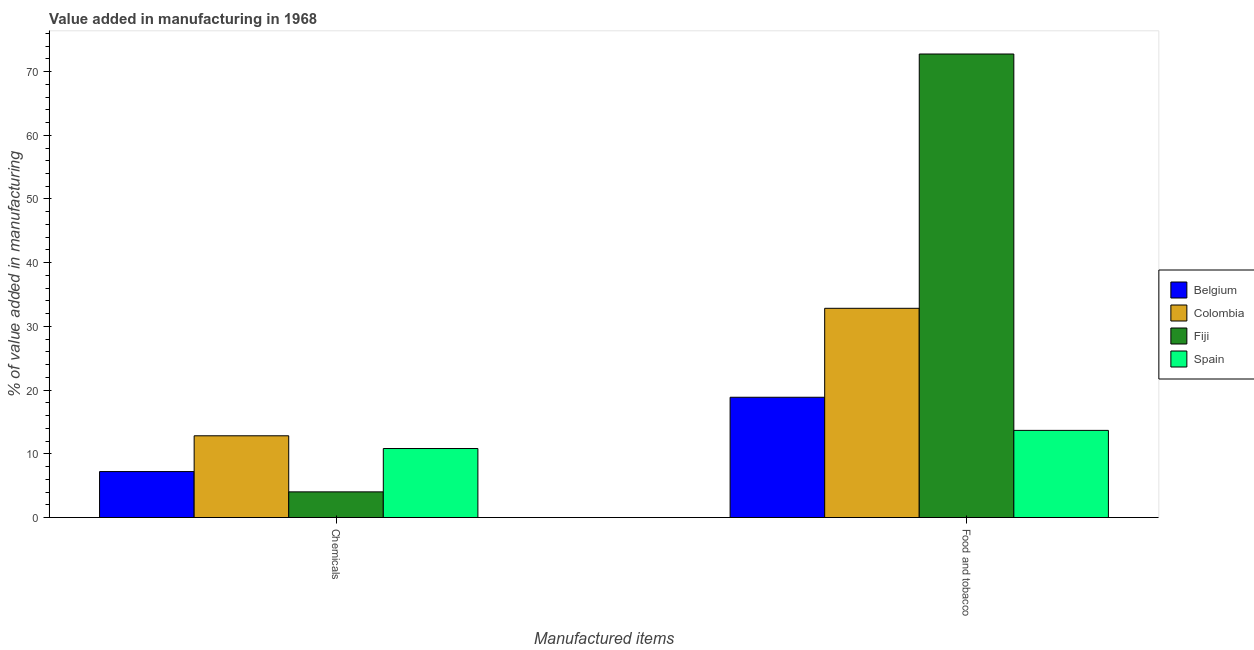How many different coloured bars are there?
Your answer should be compact. 4. How many groups of bars are there?
Offer a terse response. 2. What is the label of the 2nd group of bars from the left?
Make the answer very short. Food and tobacco. What is the value added by manufacturing food and tobacco in Spain?
Provide a succinct answer. 13.68. Across all countries, what is the maximum value added by  manufacturing chemicals?
Your answer should be very brief. 12.84. Across all countries, what is the minimum value added by manufacturing food and tobacco?
Your response must be concise. 13.68. What is the total value added by manufacturing food and tobacco in the graph?
Keep it short and to the point. 138.16. What is the difference between the value added by  manufacturing chemicals in Colombia and that in Belgium?
Your answer should be compact. 5.62. What is the difference between the value added by  manufacturing chemicals in Fiji and the value added by manufacturing food and tobacco in Colombia?
Make the answer very short. -28.81. What is the average value added by  manufacturing chemicals per country?
Offer a terse response. 8.73. What is the difference between the value added by manufacturing food and tobacco and value added by  manufacturing chemicals in Belgium?
Give a very brief answer. 11.66. What is the ratio of the value added by  manufacturing chemicals in Spain to that in Fiji?
Your answer should be very brief. 2.69. In how many countries, is the value added by manufacturing food and tobacco greater than the average value added by manufacturing food and tobacco taken over all countries?
Give a very brief answer. 1. What does the 4th bar from the right in Chemicals represents?
Provide a succinct answer. Belgium. Are the values on the major ticks of Y-axis written in scientific E-notation?
Offer a very short reply. No. Does the graph contain any zero values?
Your answer should be compact. No. How many legend labels are there?
Offer a terse response. 4. How are the legend labels stacked?
Keep it short and to the point. Vertical. What is the title of the graph?
Provide a succinct answer. Value added in manufacturing in 1968. Does "West Bank and Gaza" appear as one of the legend labels in the graph?
Offer a very short reply. No. What is the label or title of the X-axis?
Your answer should be compact. Manufactured items. What is the label or title of the Y-axis?
Keep it short and to the point. % of value added in manufacturing. What is the % of value added in manufacturing in Belgium in Chemicals?
Ensure brevity in your answer.  7.22. What is the % of value added in manufacturing of Colombia in Chemicals?
Your answer should be very brief. 12.84. What is the % of value added in manufacturing in Fiji in Chemicals?
Your response must be concise. 4.03. What is the % of value added in manufacturing of Spain in Chemicals?
Make the answer very short. 10.84. What is the % of value added in manufacturing in Belgium in Food and tobacco?
Your answer should be very brief. 18.88. What is the % of value added in manufacturing in Colombia in Food and tobacco?
Offer a very short reply. 32.84. What is the % of value added in manufacturing of Fiji in Food and tobacco?
Your response must be concise. 72.76. What is the % of value added in manufacturing in Spain in Food and tobacco?
Offer a very short reply. 13.68. Across all Manufactured items, what is the maximum % of value added in manufacturing of Belgium?
Your answer should be very brief. 18.88. Across all Manufactured items, what is the maximum % of value added in manufacturing of Colombia?
Provide a succinct answer. 32.84. Across all Manufactured items, what is the maximum % of value added in manufacturing in Fiji?
Give a very brief answer. 72.76. Across all Manufactured items, what is the maximum % of value added in manufacturing in Spain?
Your response must be concise. 13.68. Across all Manufactured items, what is the minimum % of value added in manufacturing of Belgium?
Give a very brief answer. 7.22. Across all Manufactured items, what is the minimum % of value added in manufacturing in Colombia?
Your answer should be very brief. 12.84. Across all Manufactured items, what is the minimum % of value added in manufacturing of Fiji?
Your response must be concise. 4.03. Across all Manufactured items, what is the minimum % of value added in manufacturing of Spain?
Ensure brevity in your answer.  10.84. What is the total % of value added in manufacturing of Belgium in the graph?
Your answer should be compact. 26.1. What is the total % of value added in manufacturing of Colombia in the graph?
Provide a succinct answer. 45.68. What is the total % of value added in manufacturing of Fiji in the graph?
Ensure brevity in your answer.  76.79. What is the total % of value added in manufacturing of Spain in the graph?
Ensure brevity in your answer.  24.52. What is the difference between the % of value added in manufacturing of Belgium in Chemicals and that in Food and tobacco?
Offer a very short reply. -11.66. What is the difference between the % of value added in manufacturing of Colombia in Chemicals and that in Food and tobacco?
Your answer should be compact. -20.01. What is the difference between the % of value added in manufacturing of Fiji in Chemicals and that in Food and tobacco?
Offer a terse response. -68.73. What is the difference between the % of value added in manufacturing of Spain in Chemicals and that in Food and tobacco?
Ensure brevity in your answer.  -2.85. What is the difference between the % of value added in manufacturing of Belgium in Chemicals and the % of value added in manufacturing of Colombia in Food and tobacco?
Keep it short and to the point. -25.63. What is the difference between the % of value added in manufacturing of Belgium in Chemicals and the % of value added in manufacturing of Fiji in Food and tobacco?
Offer a terse response. -65.54. What is the difference between the % of value added in manufacturing in Belgium in Chemicals and the % of value added in manufacturing in Spain in Food and tobacco?
Keep it short and to the point. -6.47. What is the difference between the % of value added in manufacturing in Colombia in Chemicals and the % of value added in manufacturing in Fiji in Food and tobacco?
Provide a succinct answer. -59.92. What is the difference between the % of value added in manufacturing in Colombia in Chemicals and the % of value added in manufacturing in Spain in Food and tobacco?
Give a very brief answer. -0.85. What is the difference between the % of value added in manufacturing of Fiji in Chemicals and the % of value added in manufacturing of Spain in Food and tobacco?
Your response must be concise. -9.65. What is the average % of value added in manufacturing in Belgium per Manufactured items?
Your answer should be compact. 13.05. What is the average % of value added in manufacturing of Colombia per Manufactured items?
Offer a terse response. 22.84. What is the average % of value added in manufacturing of Fiji per Manufactured items?
Ensure brevity in your answer.  38.39. What is the average % of value added in manufacturing in Spain per Manufactured items?
Your answer should be compact. 12.26. What is the difference between the % of value added in manufacturing in Belgium and % of value added in manufacturing in Colombia in Chemicals?
Give a very brief answer. -5.62. What is the difference between the % of value added in manufacturing in Belgium and % of value added in manufacturing in Fiji in Chemicals?
Ensure brevity in your answer.  3.19. What is the difference between the % of value added in manufacturing in Belgium and % of value added in manufacturing in Spain in Chemicals?
Ensure brevity in your answer.  -3.62. What is the difference between the % of value added in manufacturing in Colombia and % of value added in manufacturing in Fiji in Chemicals?
Provide a short and direct response. 8.8. What is the difference between the % of value added in manufacturing in Colombia and % of value added in manufacturing in Spain in Chemicals?
Provide a succinct answer. 2. What is the difference between the % of value added in manufacturing of Fiji and % of value added in manufacturing of Spain in Chemicals?
Your answer should be compact. -6.8. What is the difference between the % of value added in manufacturing in Belgium and % of value added in manufacturing in Colombia in Food and tobacco?
Your answer should be very brief. -13.96. What is the difference between the % of value added in manufacturing of Belgium and % of value added in manufacturing of Fiji in Food and tobacco?
Make the answer very short. -53.88. What is the difference between the % of value added in manufacturing in Belgium and % of value added in manufacturing in Spain in Food and tobacco?
Give a very brief answer. 5.2. What is the difference between the % of value added in manufacturing in Colombia and % of value added in manufacturing in Fiji in Food and tobacco?
Provide a short and direct response. -39.91. What is the difference between the % of value added in manufacturing of Colombia and % of value added in manufacturing of Spain in Food and tobacco?
Provide a short and direct response. 19.16. What is the difference between the % of value added in manufacturing in Fiji and % of value added in manufacturing in Spain in Food and tobacco?
Your answer should be compact. 59.07. What is the ratio of the % of value added in manufacturing in Belgium in Chemicals to that in Food and tobacco?
Ensure brevity in your answer.  0.38. What is the ratio of the % of value added in manufacturing in Colombia in Chemicals to that in Food and tobacco?
Provide a succinct answer. 0.39. What is the ratio of the % of value added in manufacturing of Fiji in Chemicals to that in Food and tobacco?
Your answer should be very brief. 0.06. What is the ratio of the % of value added in manufacturing of Spain in Chemicals to that in Food and tobacco?
Ensure brevity in your answer.  0.79. What is the difference between the highest and the second highest % of value added in manufacturing of Belgium?
Make the answer very short. 11.66. What is the difference between the highest and the second highest % of value added in manufacturing in Colombia?
Offer a terse response. 20.01. What is the difference between the highest and the second highest % of value added in manufacturing of Fiji?
Your answer should be compact. 68.73. What is the difference between the highest and the second highest % of value added in manufacturing in Spain?
Ensure brevity in your answer.  2.85. What is the difference between the highest and the lowest % of value added in manufacturing in Belgium?
Provide a short and direct response. 11.66. What is the difference between the highest and the lowest % of value added in manufacturing of Colombia?
Keep it short and to the point. 20.01. What is the difference between the highest and the lowest % of value added in manufacturing of Fiji?
Keep it short and to the point. 68.73. What is the difference between the highest and the lowest % of value added in manufacturing of Spain?
Ensure brevity in your answer.  2.85. 